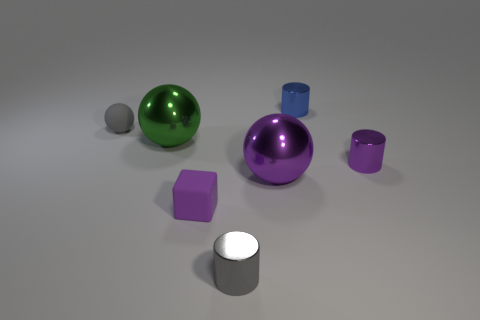There is a metallic thing that is the same color as the tiny sphere; what is its shape?
Your answer should be compact. Cylinder. Is the shape of the gray thing in front of the tiny cube the same as the gray object behind the tiny gray shiny cylinder?
Your answer should be compact. No. What is the size of the shiny cylinder that is both behind the matte block and in front of the big green metal object?
Keep it short and to the point. Small. There is another matte thing that is the same shape as the big green thing; what color is it?
Provide a succinct answer. Gray. There is a metallic ball right of the tiny cube that is in front of the small blue shiny object; what color is it?
Make the answer very short. Purple. What is the shape of the blue shiny object?
Your response must be concise. Cylinder. What is the shape of the small metal object that is left of the tiny purple metal object and in front of the big green metal ball?
Provide a short and direct response. Cylinder. What color is the small ball that is made of the same material as the small block?
Ensure brevity in your answer.  Gray. There is a tiny shiny object behind the small gray object on the left side of the small cylinder that is in front of the purple ball; what is its shape?
Your answer should be very brief. Cylinder. What is the size of the purple cylinder?
Offer a very short reply. Small. 